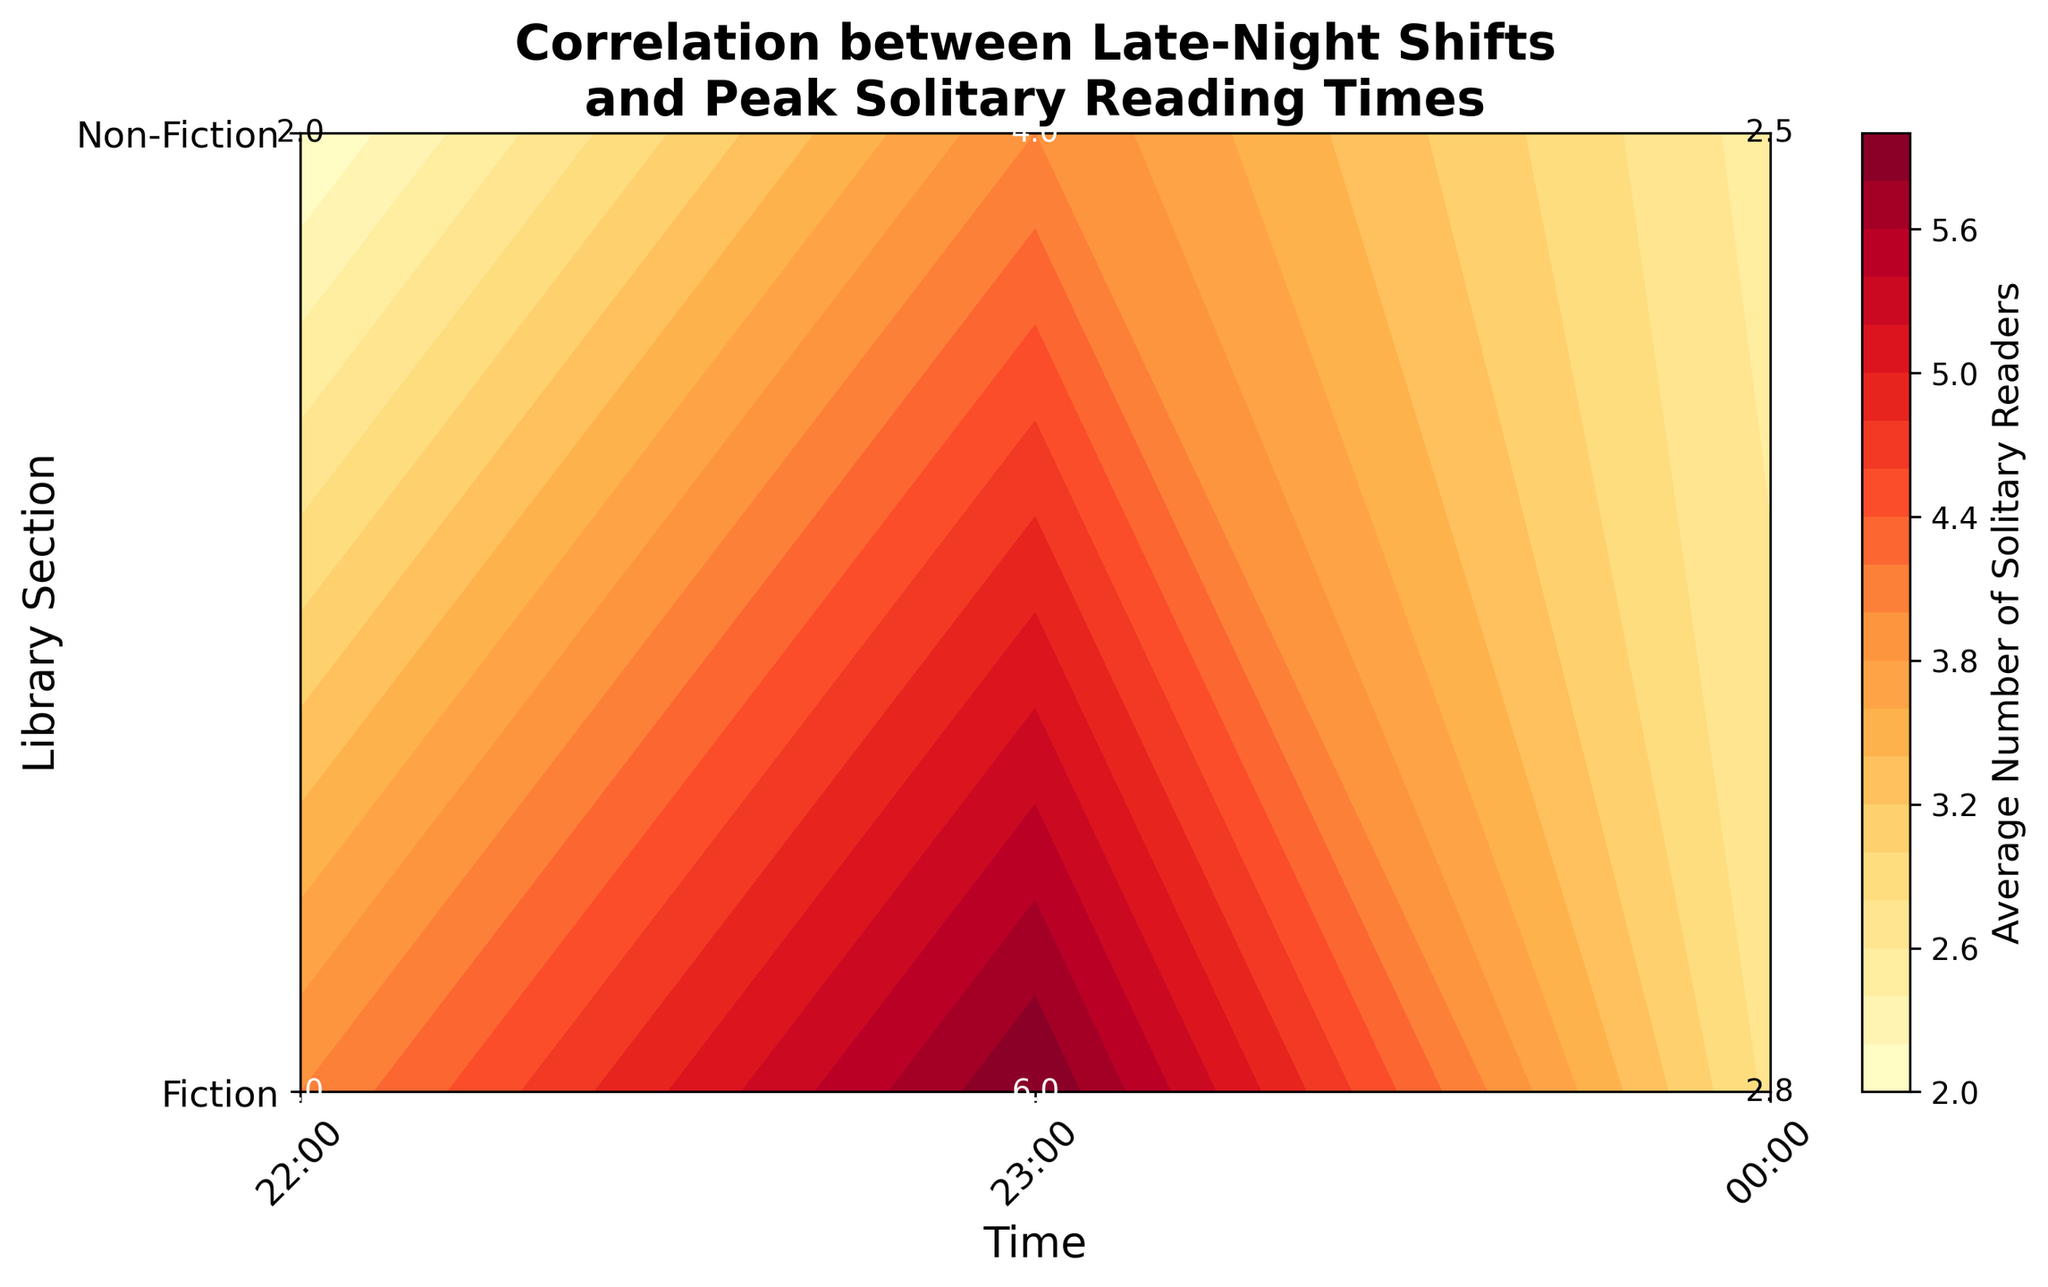What is the title of the plot? The title is located at the top of the plot and summarizes what the plot represents.
Answer: Correlation between Late-Night Shifts and Peak Solitary Reading Times What are the library sections included in the plot? The library sections are labeled on the y-axis.
Answer: Fiction, Non-Fiction At what time is the peak average number of solitary readers for the Fiction section? To find the peak, look for the highest value under the Fiction section along the x-axis times. This can be identified through the contour plot's annotations or color intensity.
Answer: 23:00 How do the solitary reader averages in the Fiction section compare to the Non-Fiction at 22:00? Identify the values for Fiction and Non-Fiction at 22:00 from the plot's annotations and compare them.
Answer: Fiction has a higher average than Non-Fiction Which time slot has the lowest average number of solitary readers for Non-Fiction? Find the minimum value in the Non-Fiction section along the x-axis times.
Answer: 00:00 What is the color range used in the contour plot? The color range is visible through the gradients in the plot and the color bar.
Answer: Shades of Yellow to Red What is the average number of solitary readers at 22:00 across both sections? Sum the average number of solitary readers for both Fiction and Non-Fiction at 22:00 and divide by 2.
Answer: (4.0 + 2.0) / 2 = 3.0 Are there any time slots where Fiction and Non-Fiction have the same average number of solitary readers? Check for any identical values between the two library sections across all given times.
Answer: No, their averages are different at each time slot Which library section shows a greater variation in the number of solitary readers over the three time slots? Compare the range of values for the Fiction and Non-Fiction sections.
Answer: Fiction has a greater variation What average number of solitary readers should be expected in the Non-Fiction section at midnight (00:00)? Look at the value annotated for 00:00 in the Non-Fiction section.
Answer: 2.5 